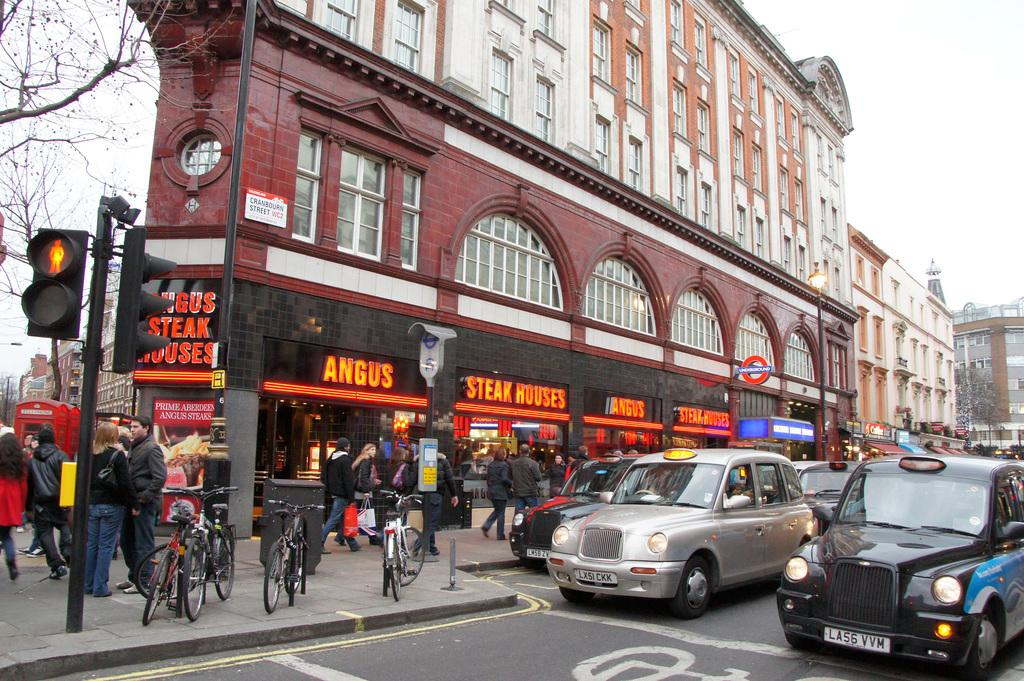<image>
Render a clear and concise summary of the photo. A busy sidewalk with people and bikes on it and signs that say Angus Steak Houses 